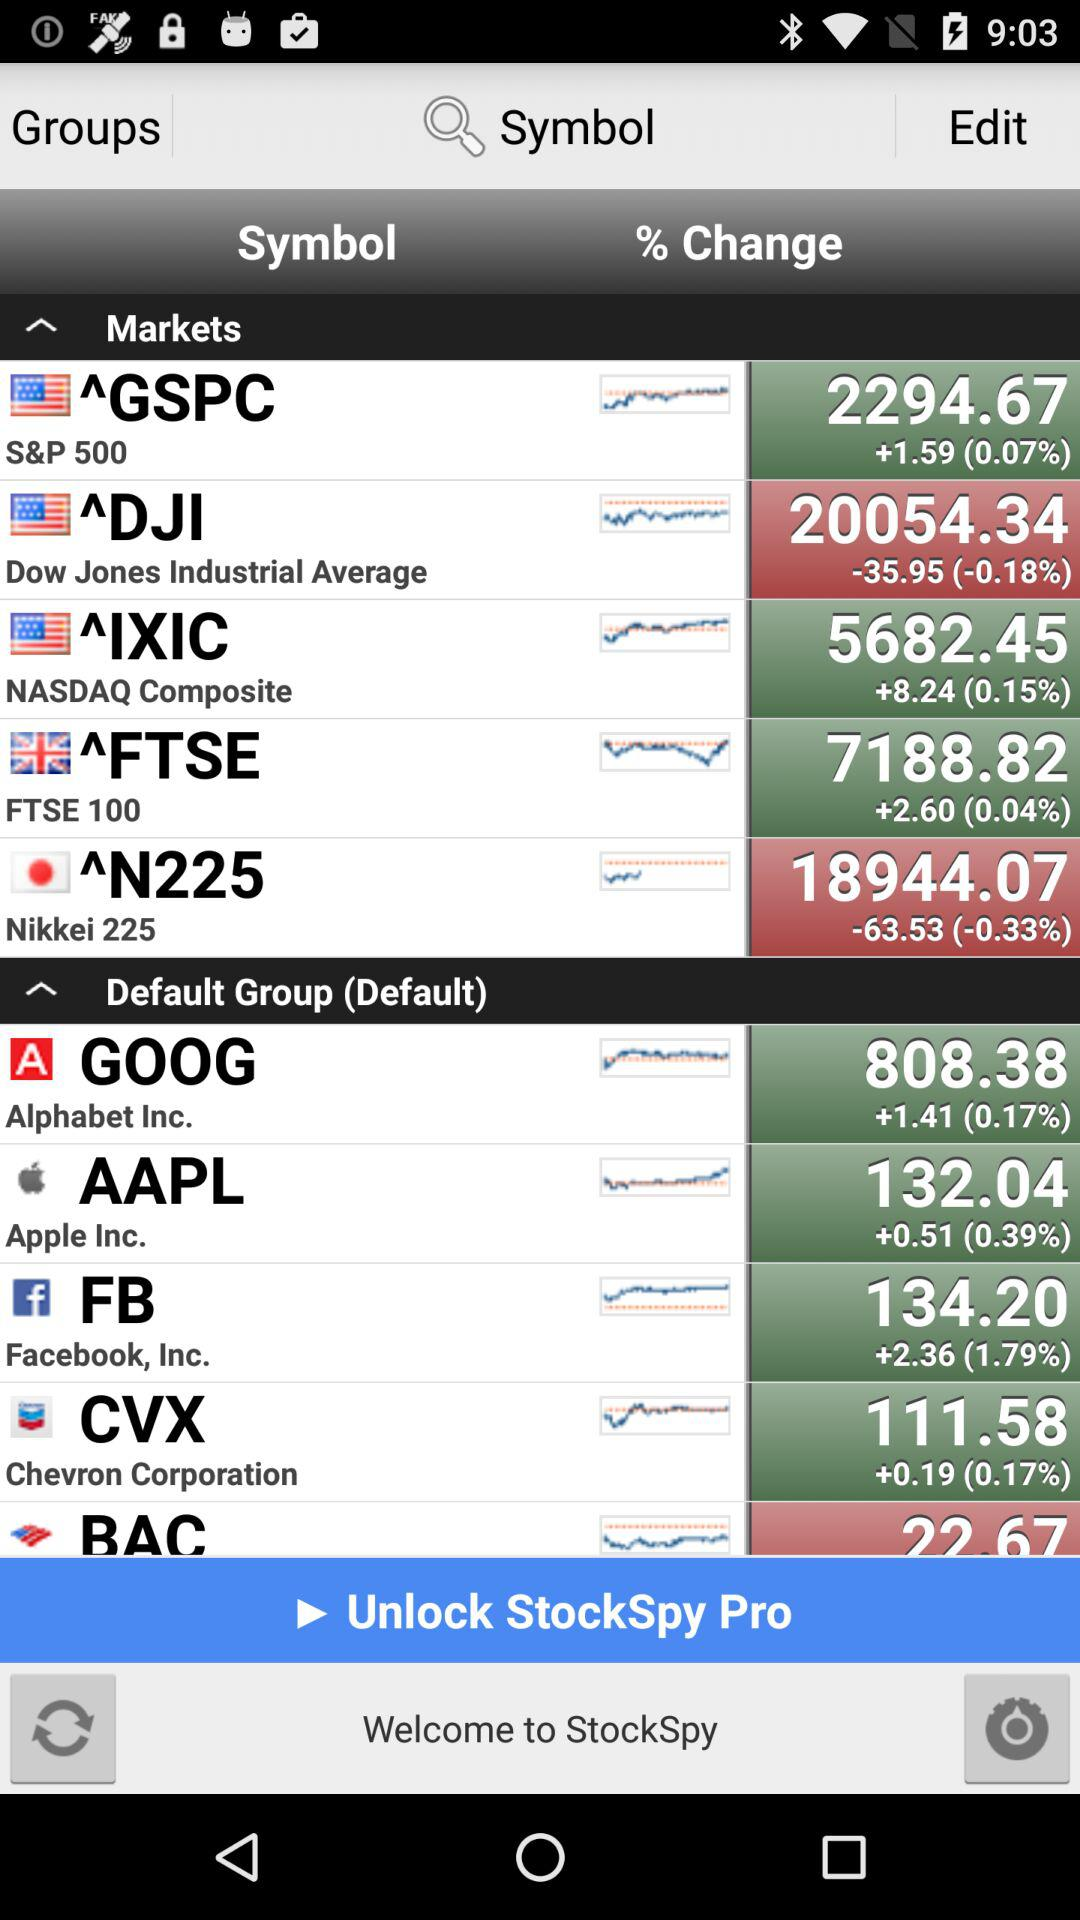+0.19 points raised for which company? The company is Chevron Corporation. 